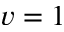<formula> <loc_0><loc_0><loc_500><loc_500>v = 1</formula> 